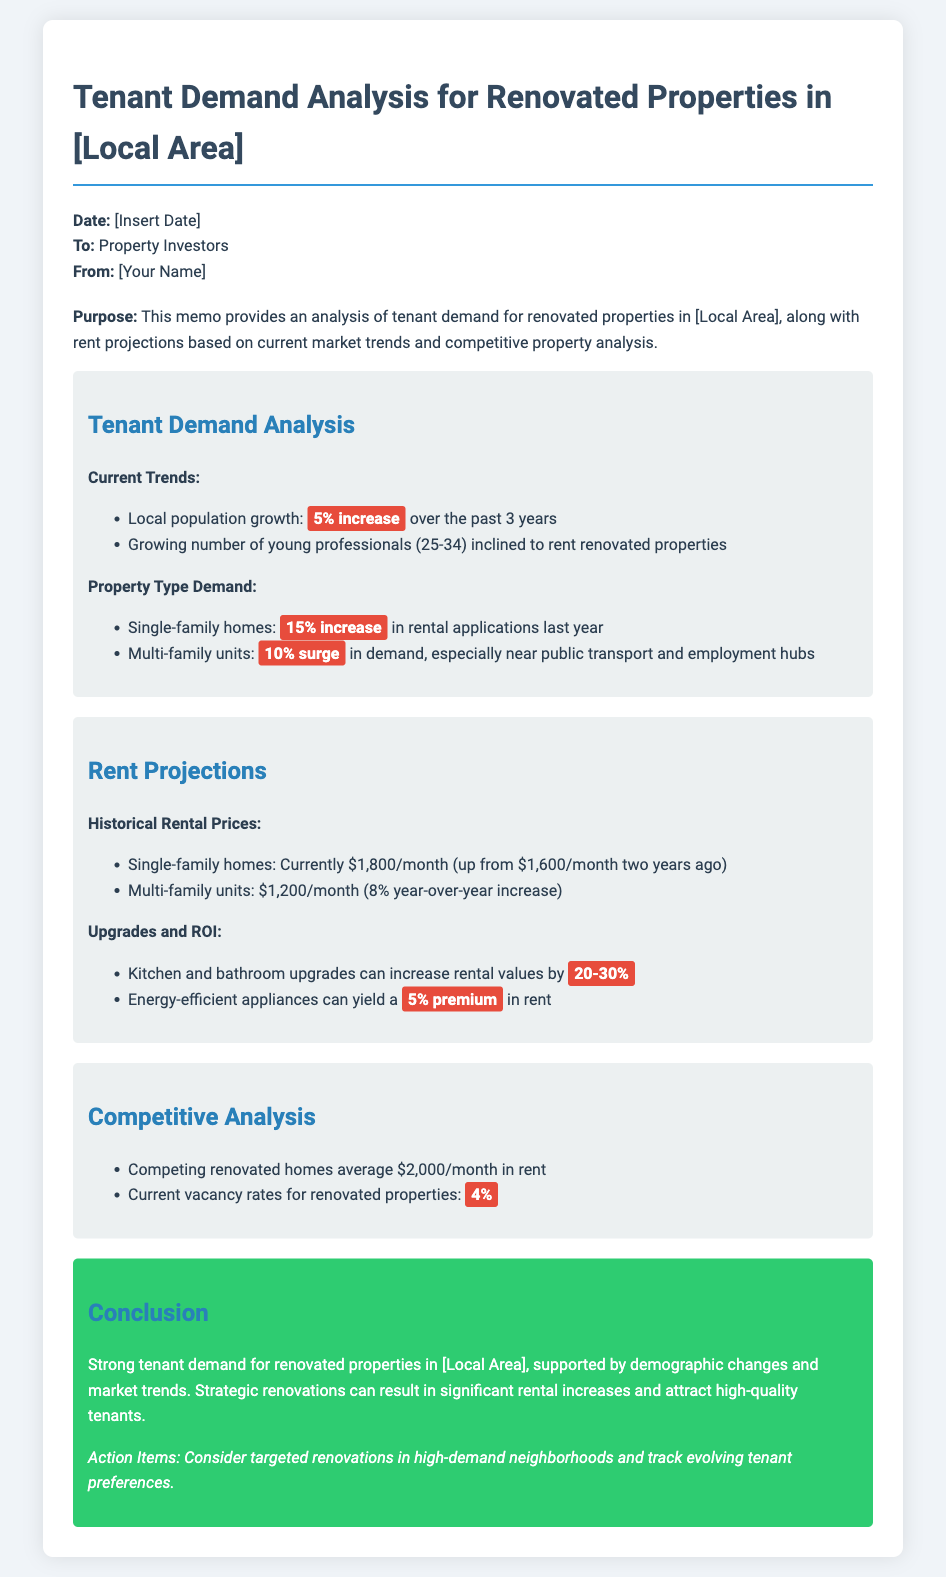what is the local population growth percentage? The document states there is a 5% increase in local population over the past 3 years.
Answer: 5% what is the current rental price for single-family homes? The memo indicates that the current rent for single-family homes is $1,800/month.
Answer: $1,800/month what is the average rent for competing renovated homes? According to the document, competing renovated homes average $2,000/month in rent.
Answer: $2,000/month how much can kitchen and bathroom upgrades increase rental values? The memo specifies that kitchen and bathroom upgrades can increase rental values by 20-30%.
Answer: 20-30% what is the average current vacancy rate for renovated properties? The document mentions that the current vacancy rates for renovated properties are 4%.
Answer: 4% what type of tenants is the analysis focused on? The analysis focuses on young professionals aged 25-34 who are inclined to rent renovated properties.
Answer: young professionals (25-34) what strategic action is suggested in the conclusion? The conclusion suggests considering targeted renovations in high-demand neighborhoods.
Answer: targeted renovations in high-demand neighborhoods what is the year-over-year increase in rental prices for multi-family units? The memo states that multi-family units have an 8% year-over-year increase in rental prices.
Answer: 8% what is the projected rent premium for energy-efficient appliances? According to the memo, energy-efficient appliances can yield a 5% premium in rent.
Answer: 5% 